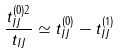Convert formula to latex. <formula><loc_0><loc_0><loc_500><loc_500>\frac { t _ { I J } ^ { ( 0 ) 2 } } { t _ { I J } } \simeq t _ { I J } ^ { ( 0 ) } - t _ { I J } ^ { ( 1 ) }</formula> 